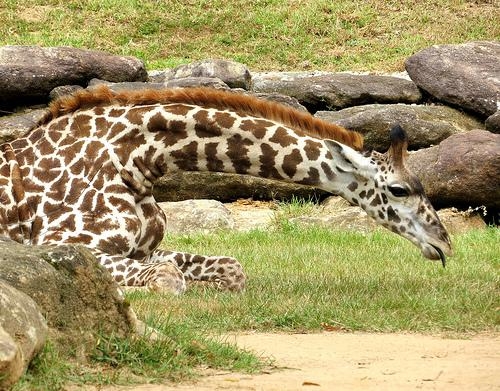Question: what animal is shown?
Choices:
A. Elephant.
B. Zebra.
C. Giraffe.
D. Tiger.
Answer with the letter. Answer: C Question: where is the animal?
Choices:
A. Laying in grass.
B. In a tree.
C. Edge of water.
D. On a rock.
Answer with the letter. Answer: A Question: what is in behind the giraffe?
Choices:
A. Trees and grass.
B. Calf and Zookeeper.
C. Rocks and grass.
D. Gate and tourists.
Answer with the letter. Answer: C 